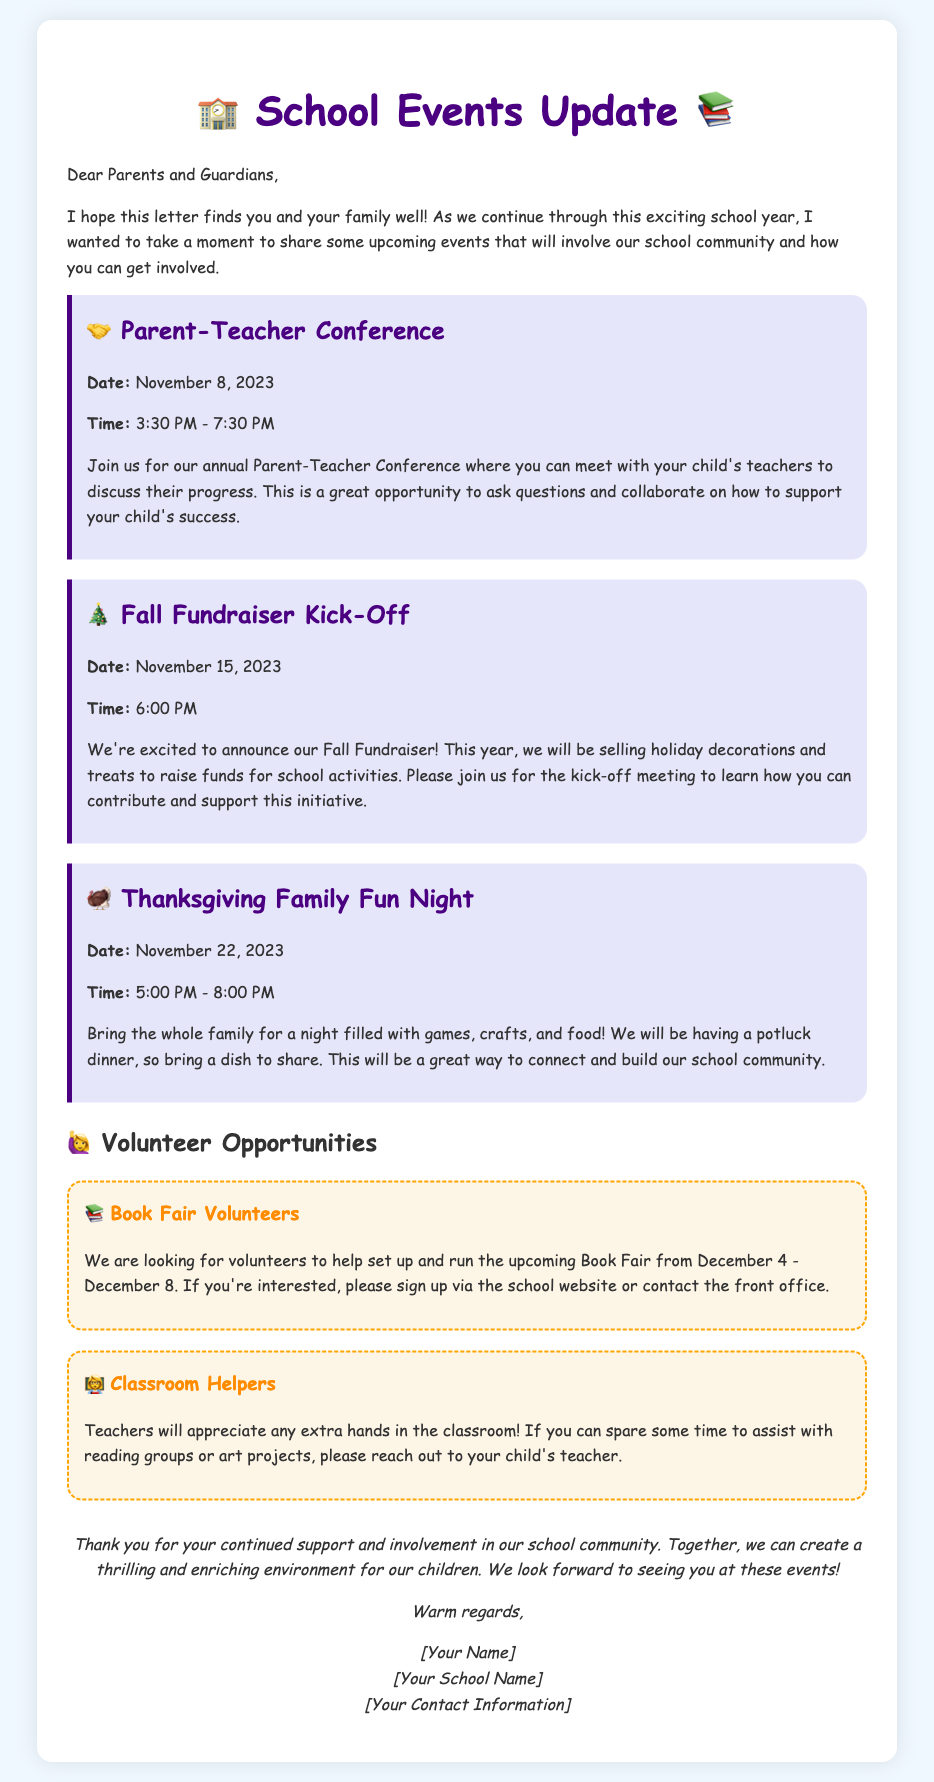what is the date of the Parent-Teacher Conference? The document explicitly states the date of the Parent-Teacher Conference.
Answer: November 8, 2023 what time does the Fall Fundraiser Kick-Off start? The document provides the starting time for the Fall Fundraiser Kick-Off event.
Answer: 6:00 PM what is the recommended contribution for the Thanksgiving Family Fun Night? The document mentions that attendees should bring a dish to share for the potluck dinner.
Answer: a dish to share how long will the Book Fair take place? The document indicates the start and end dates of the Book Fair.
Answer: December 4 - December 8 what is the focus of the Fall Fundraiser? The document details the purpose of the Fall Fundraiser, which highlights what will be sold.
Answer: holiday decorations and treats how can parents get involved with classroom activities? The document outlines what parents can do to help in the classroom according to teachers' needs.
Answer: assist with reading groups or art projects what is the main objective of the Parent-Teacher Conference? The document describes the purpose of the Parent-Teacher Conference, focusing on student progress.
Answer: discuss their progress who should be contacted for volunteering opportunities? The document mentions a specific way to sign up for volunteering positions.
Answer: the school website or contact the front office 